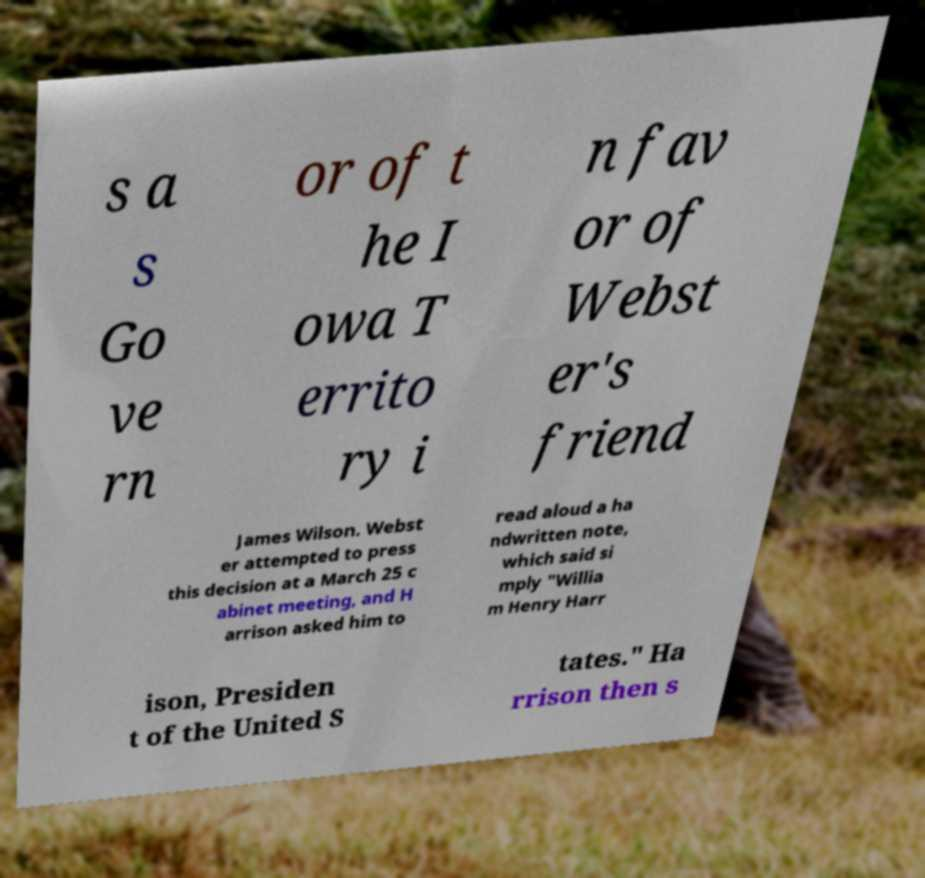Could you extract and type out the text from this image? s a s Go ve rn or of t he I owa T errito ry i n fav or of Webst er's friend James Wilson. Webst er attempted to press this decision at a March 25 c abinet meeting, and H arrison asked him to read aloud a ha ndwritten note, which said si mply "Willia m Henry Harr ison, Presiden t of the United S tates." Ha rrison then s 